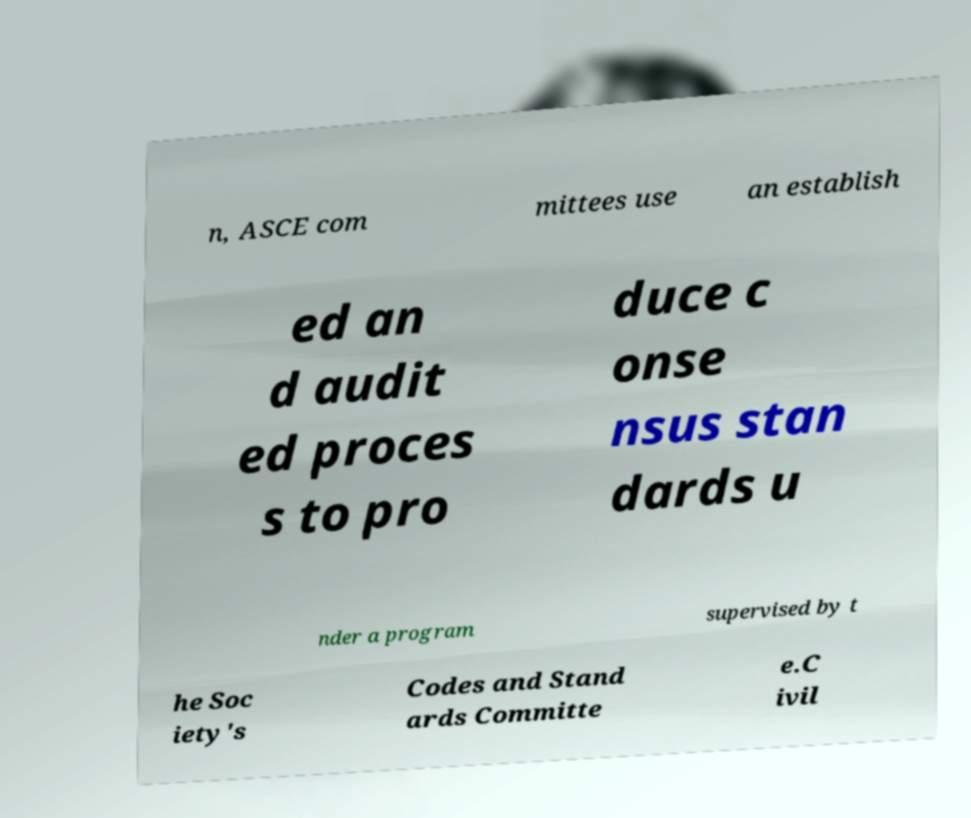Can you accurately transcribe the text from the provided image for me? n, ASCE com mittees use an establish ed an d audit ed proces s to pro duce c onse nsus stan dards u nder a program supervised by t he Soc iety's Codes and Stand ards Committe e.C ivil 